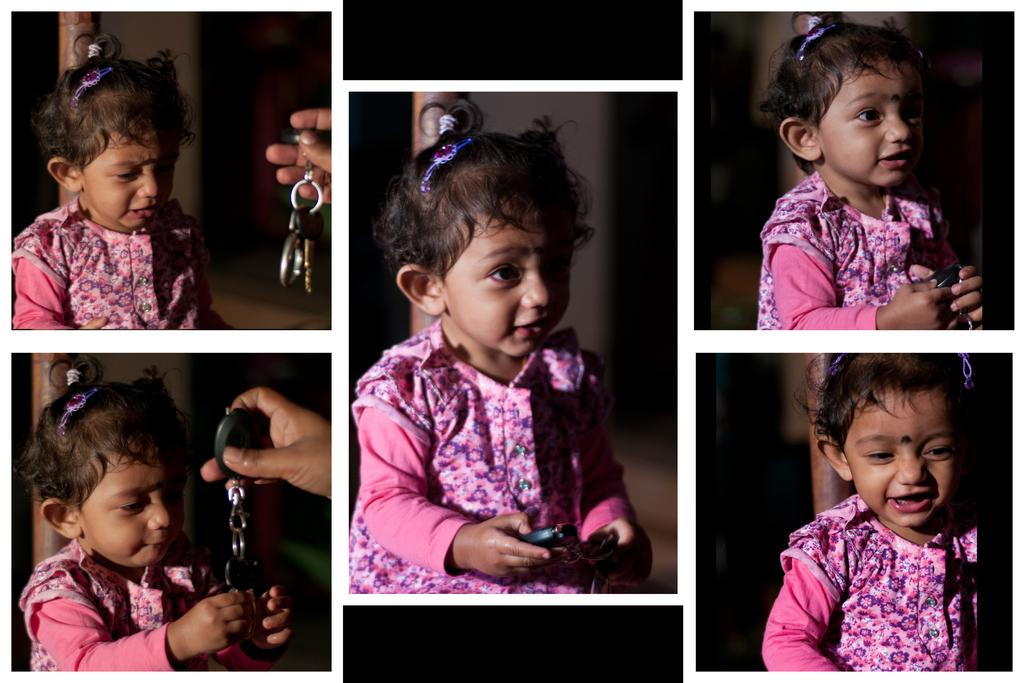What is the girl in the image doing? The girl in the image is giving expressions. Can you describe the actions of the person in the image? The person in the image is holding keys. What type of desk can be seen in the image? There is no desk present in the image. Can you describe the church in the image? There is no church present in the image. 